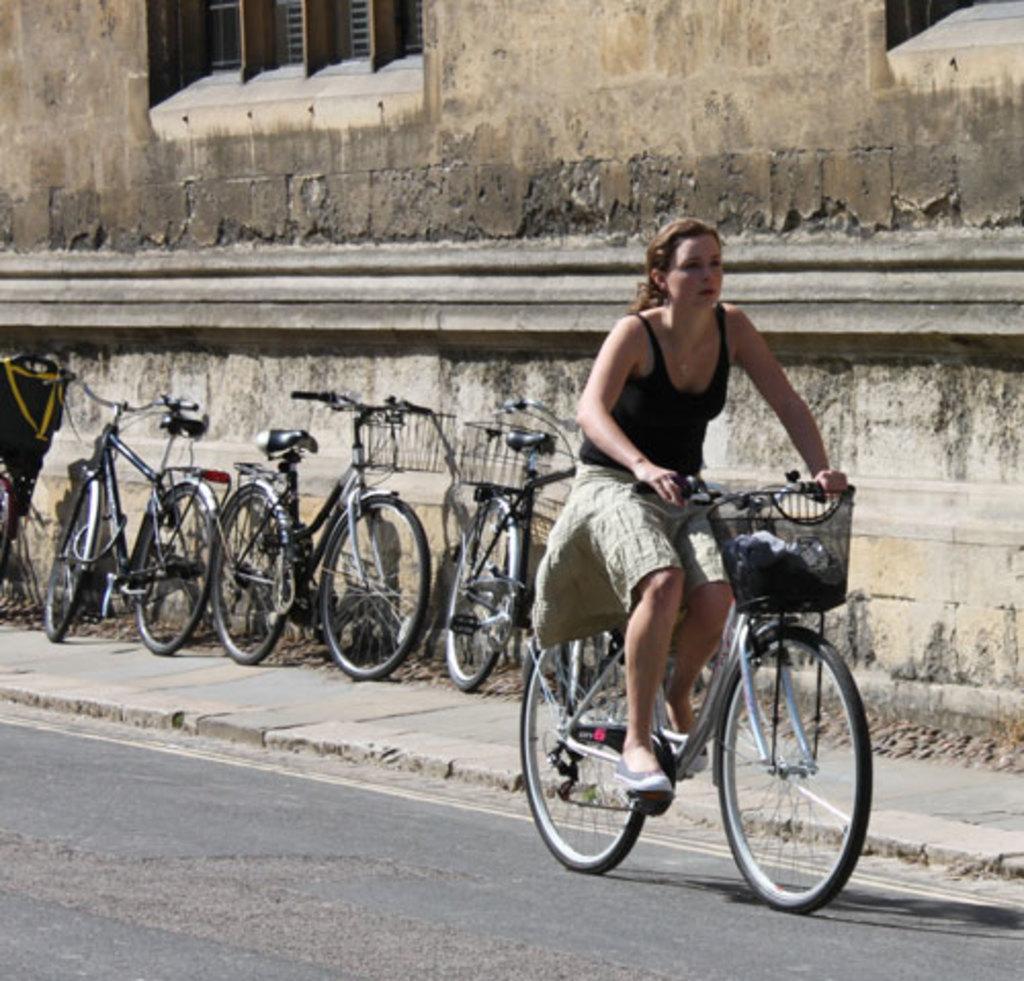What is the setting of the image? The image is on a road. What is the woman in the image doing? The woman is riding a bicycle on the road. Are there any other bicycles visible in the image? Yes, there are many bicycles on the footpath at the back. What can be seen in the background of the image? There is a building visible at the back. What type of patch is the woman using to repair her bicycle in the image? There is no patch visible in the image, nor is the woman repairing her bicycle. 